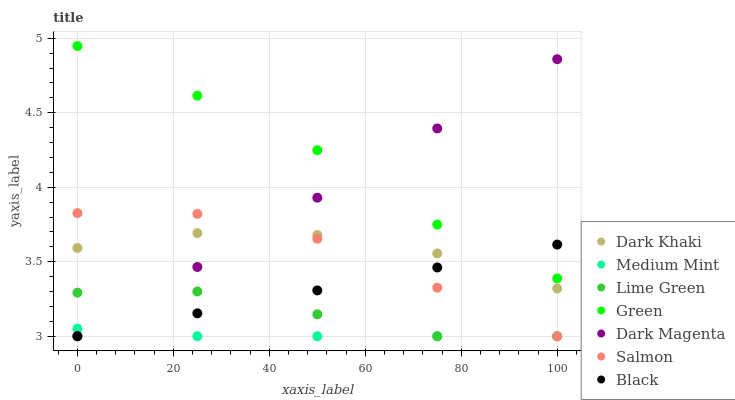Does Medium Mint have the minimum area under the curve?
Answer yes or no. Yes. Does Green have the maximum area under the curve?
Answer yes or no. Yes. Does Dark Magenta have the minimum area under the curve?
Answer yes or no. No. Does Dark Magenta have the maximum area under the curve?
Answer yes or no. No. Is Dark Magenta the smoothest?
Answer yes or no. Yes. Is Dark Khaki the roughest?
Answer yes or no. Yes. Is Salmon the smoothest?
Answer yes or no. No. Is Salmon the roughest?
Answer yes or no. No. Does Medium Mint have the lowest value?
Answer yes or no. Yes. Does Dark Khaki have the lowest value?
Answer yes or no. No. Does Green have the highest value?
Answer yes or no. Yes. Does Dark Magenta have the highest value?
Answer yes or no. No. Is Salmon less than Green?
Answer yes or no. Yes. Is Dark Khaki greater than Lime Green?
Answer yes or no. Yes. Does Salmon intersect Lime Green?
Answer yes or no. Yes. Is Salmon less than Lime Green?
Answer yes or no. No. Is Salmon greater than Lime Green?
Answer yes or no. No. Does Salmon intersect Green?
Answer yes or no. No. 